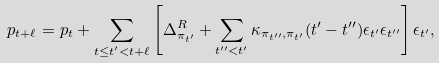<formula> <loc_0><loc_0><loc_500><loc_500>p _ { t + \ell } = p _ { t } + \sum _ { t \leq t ^ { \prime } < t + \ell } \left [ \Delta ^ { R } _ { \pi _ { t ^ { \prime } } } + \sum _ { t ^ { \prime \prime } < t ^ { \prime } } \kappa _ { \pi _ { t ^ { \prime \prime } } , \pi _ { t ^ { \prime } } } ( t ^ { \prime } - t ^ { \prime \prime } ) \epsilon _ { t ^ { \prime } } \epsilon _ { t ^ { \prime \prime } } \right ] \epsilon _ { t ^ { \prime } } ,</formula> 